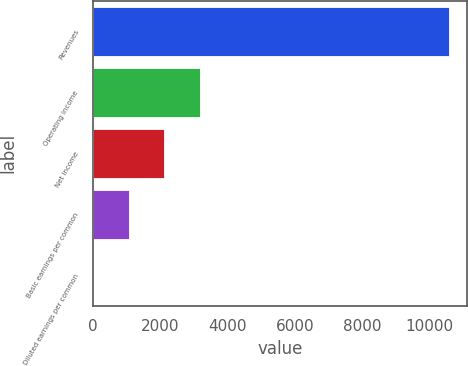Convert chart. <chart><loc_0><loc_0><loc_500><loc_500><bar_chart><fcel>Revenues<fcel>Operating income<fcel>Net income<fcel>Basic earnings per common<fcel>Diluted earnings per common<nl><fcel>10564<fcel>3170.36<fcel>2114.12<fcel>1057.89<fcel>1.65<nl></chart> 